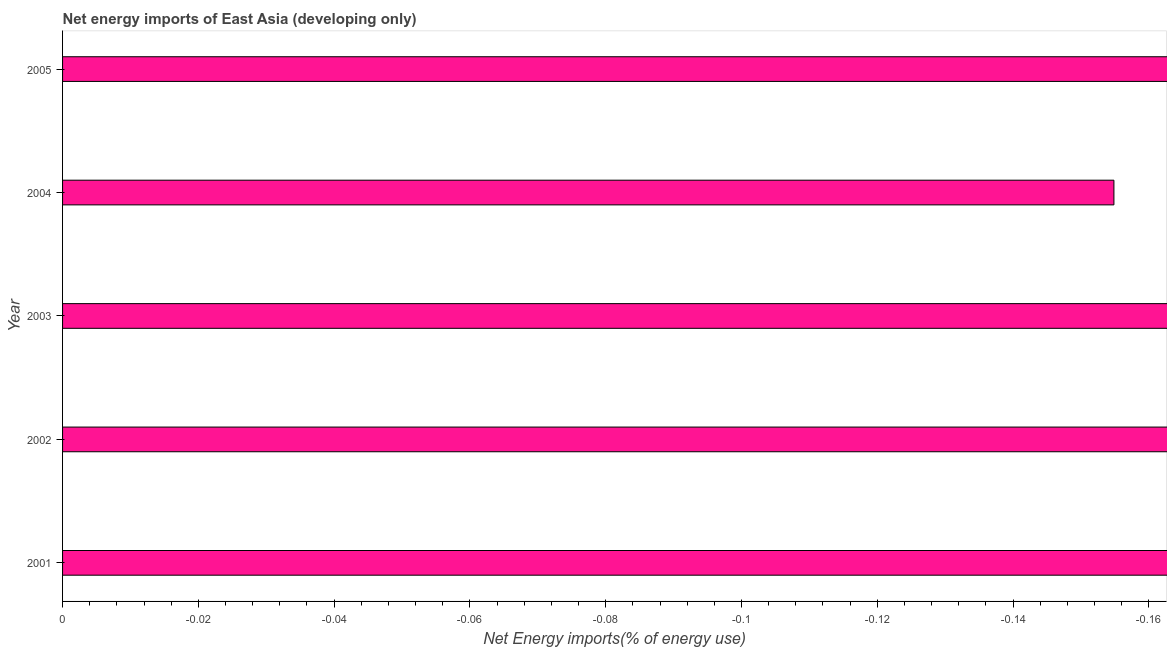Does the graph contain grids?
Ensure brevity in your answer.  No. What is the title of the graph?
Offer a very short reply. Net energy imports of East Asia (developing only). What is the label or title of the X-axis?
Make the answer very short. Net Energy imports(% of energy use). What is the energy imports in 2003?
Make the answer very short. 0. Across all years, what is the minimum energy imports?
Provide a succinct answer. 0. What is the average energy imports per year?
Ensure brevity in your answer.  0. In how many years, is the energy imports greater than -0.096 %?
Keep it short and to the point. 0. How many bars are there?
Your answer should be compact. 0. Are all the bars in the graph horizontal?
Your answer should be very brief. Yes. What is the difference between two consecutive major ticks on the X-axis?
Keep it short and to the point. 0.02. What is the Net Energy imports(% of energy use) of 2003?
Ensure brevity in your answer.  0. What is the Net Energy imports(% of energy use) in 2005?
Offer a very short reply. 0. 